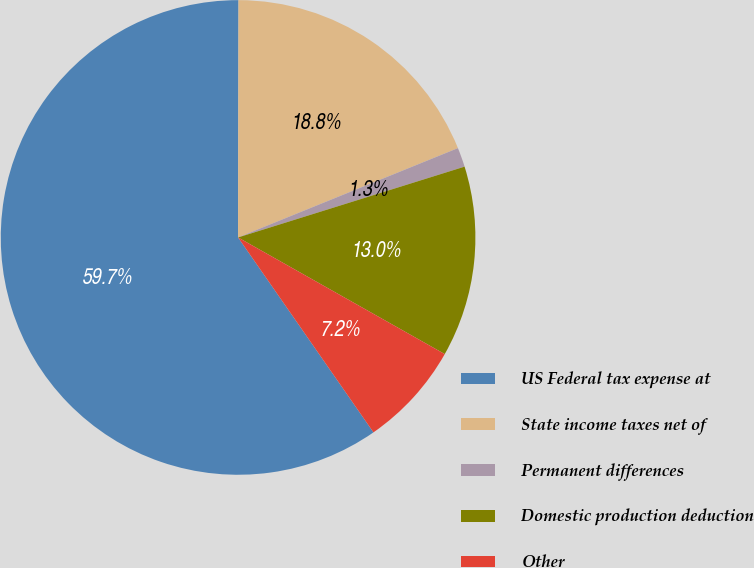Convert chart. <chart><loc_0><loc_0><loc_500><loc_500><pie_chart><fcel>US Federal tax expense at<fcel>State income taxes net of<fcel>Permanent differences<fcel>Domestic production deduction<fcel>Other<nl><fcel>59.69%<fcel>18.83%<fcel>1.32%<fcel>13.0%<fcel>7.16%<nl></chart> 